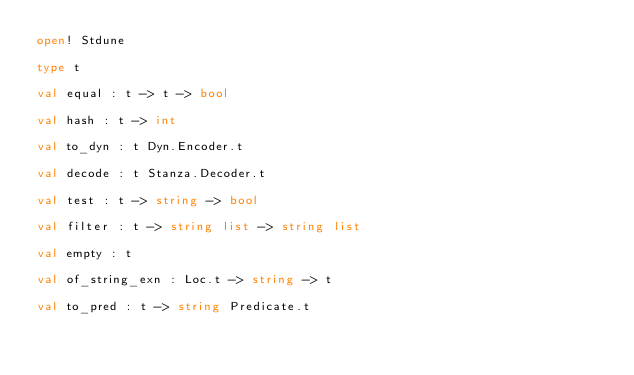Convert code to text. <code><loc_0><loc_0><loc_500><loc_500><_OCaml_>open! Stdune

type t

val equal : t -> t -> bool

val hash : t -> int

val to_dyn : t Dyn.Encoder.t

val decode : t Stanza.Decoder.t

val test : t -> string -> bool

val filter : t -> string list -> string list

val empty : t

val of_string_exn : Loc.t -> string -> t

val to_pred : t -> string Predicate.t
</code> 